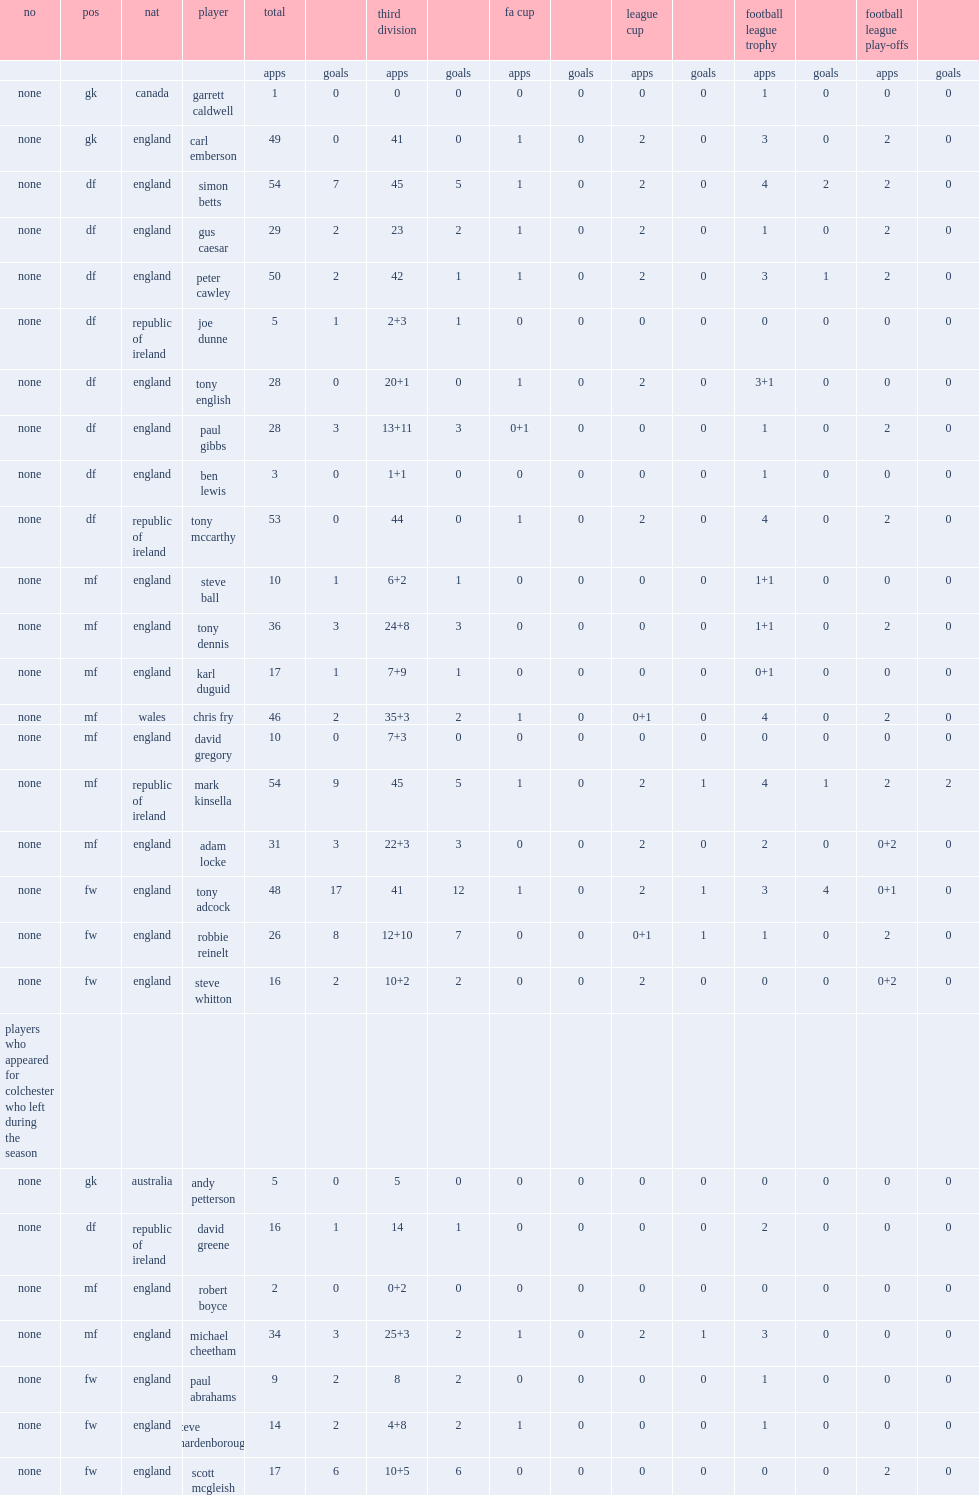What matches did colchester united f.c. participated in? Third division fa cup league cup football league trophy. 